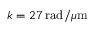<formula> <loc_0><loc_0><loc_500><loc_500>k = 2 7 \, r a d / \mu m</formula> 